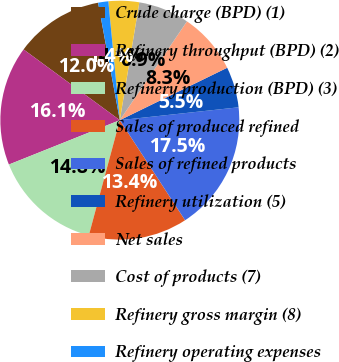Convert chart to OTSL. <chart><loc_0><loc_0><loc_500><loc_500><pie_chart><fcel>Crude charge (BPD) (1)<fcel>Refinery throughput (BPD) (2)<fcel>Refinery production (BPD) (3)<fcel>Sales of produced refined<fcel>Sales of refined products<fcel>Refinery utilization (5)<fcel>Net sales<fcel>Cost of products (7)<fcel>Refinery gross margin (8)<fcel>Refinery operating expenses<nl><fcel>12.0%<fcel>16.14%<fcel>14.76%<fcel>13.38%<fcel>17.52%<fcel>5.51%<fcel>8.27%<fcel>6.89%<fcel>4.14%<fcel>1.38%<nl></chart> 